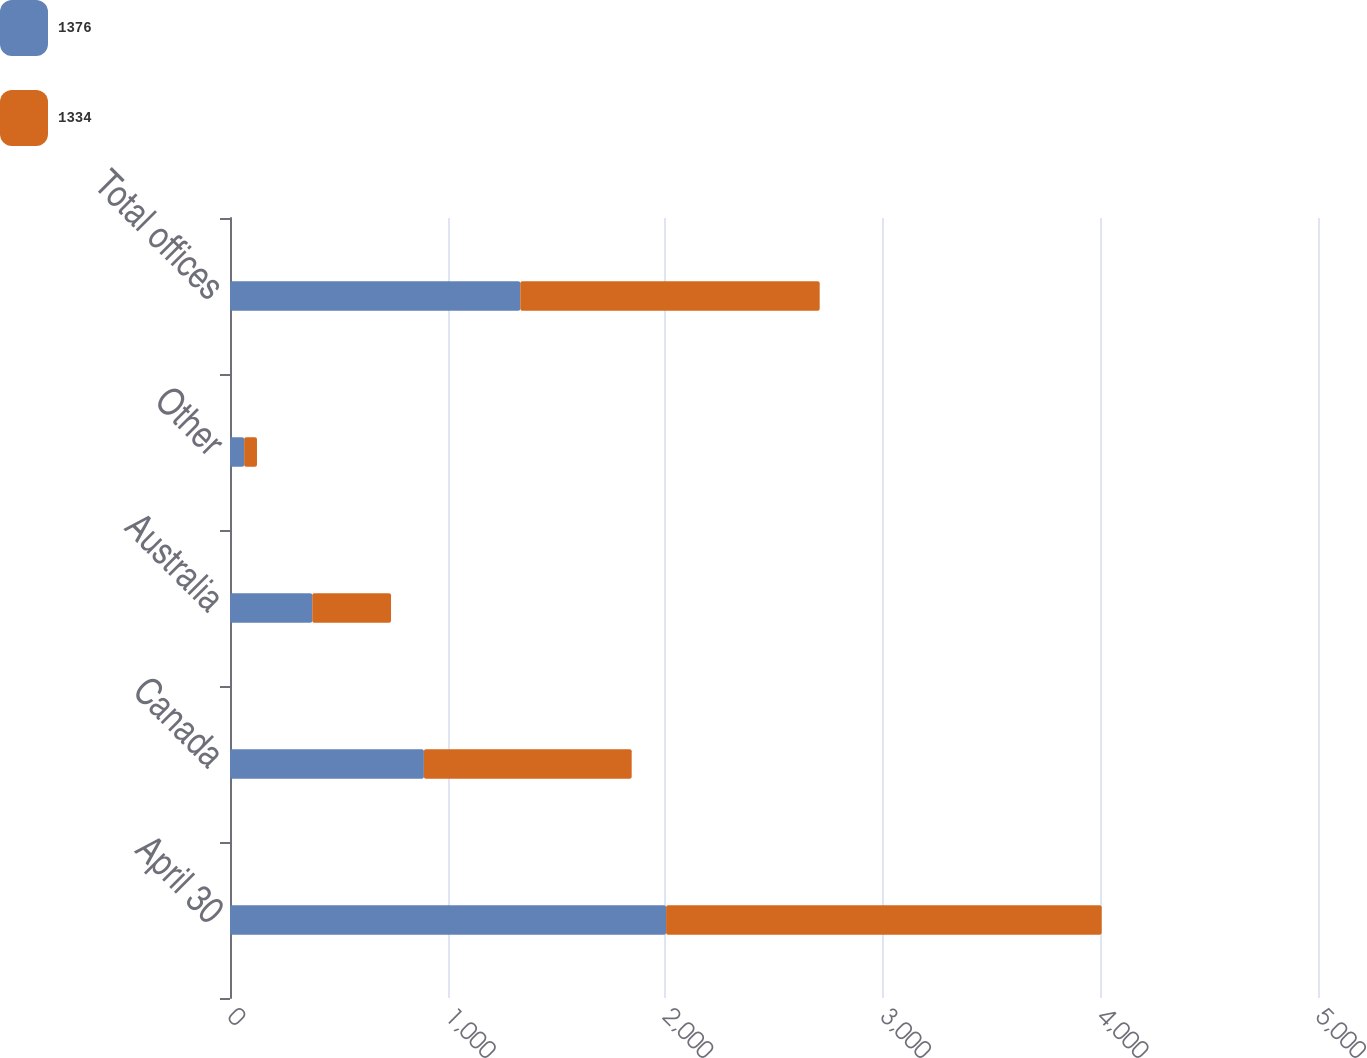<chart> <loc_0><loc_0><loc_500><loc_500><stacked_bar_chart><ecel><fcel>April 30<fcel>Canada<fcel>Australia<fcel>Other<fcel>Total offices<nl><fcel>1376<fcel>2004<fcel>891<fcel>378<fcel>65<fcel>1334<nl><fcel>1334<fcel>2002<fcel>955<fcel>362<fcel>59<fcel>1376<nl></chart> 